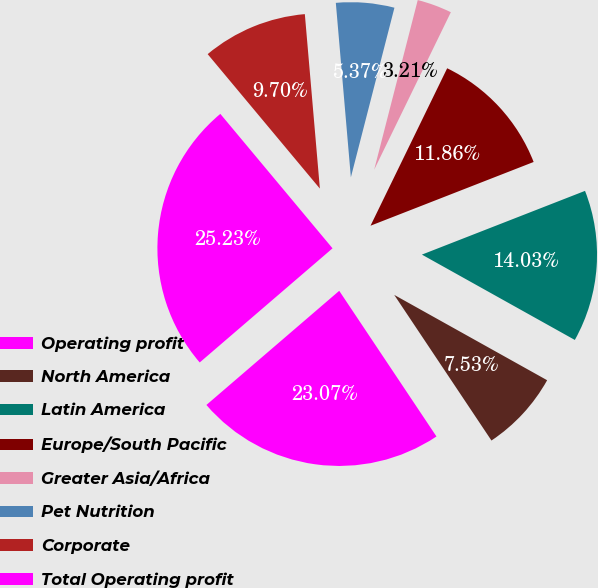Convert chart. <chart><loc_0><loc_0><loc_500><loc_500><pie_chart><fcel>Operating profit<fcel>North America<fcel>Latin America<fcel>Europe/South Pacific<fcel>Greater Asia/Africa<fcel>Pet Nutrition<fcel>Corporate<fcel>Total Operating profit<nl><fcel>23.07%<fcel>7.53%<fcel>14.03%<fcel>11.86%<fcel>3.21%<fcel>5.37%<fcel>9.7%<fcel>25.23%<nl></chart> 